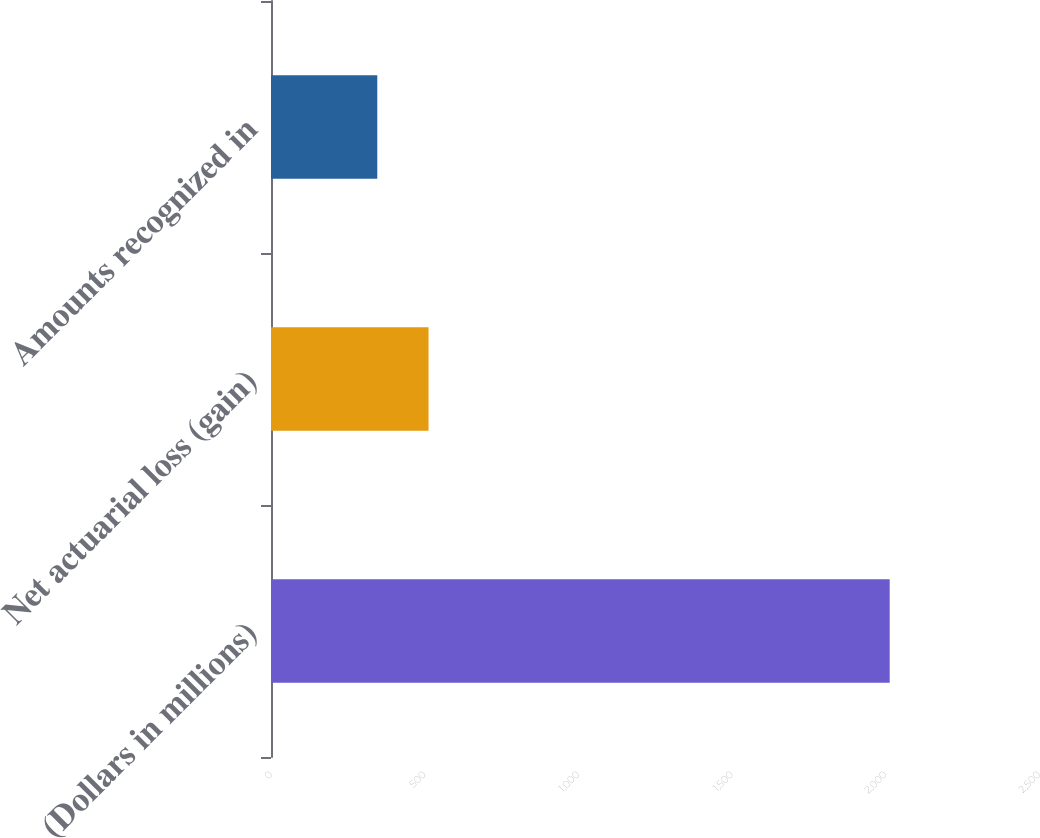Convert chart. <chart><loc_0><loc_0><loc_500><loc_500><bar_chart><fcel>(Dollars in millions)<fcel>Net actuarial loss (gain)<fcel>Amounts recognized in<nl><fcel>2014<fcel>512.8<fcel>346<nl></chart> 